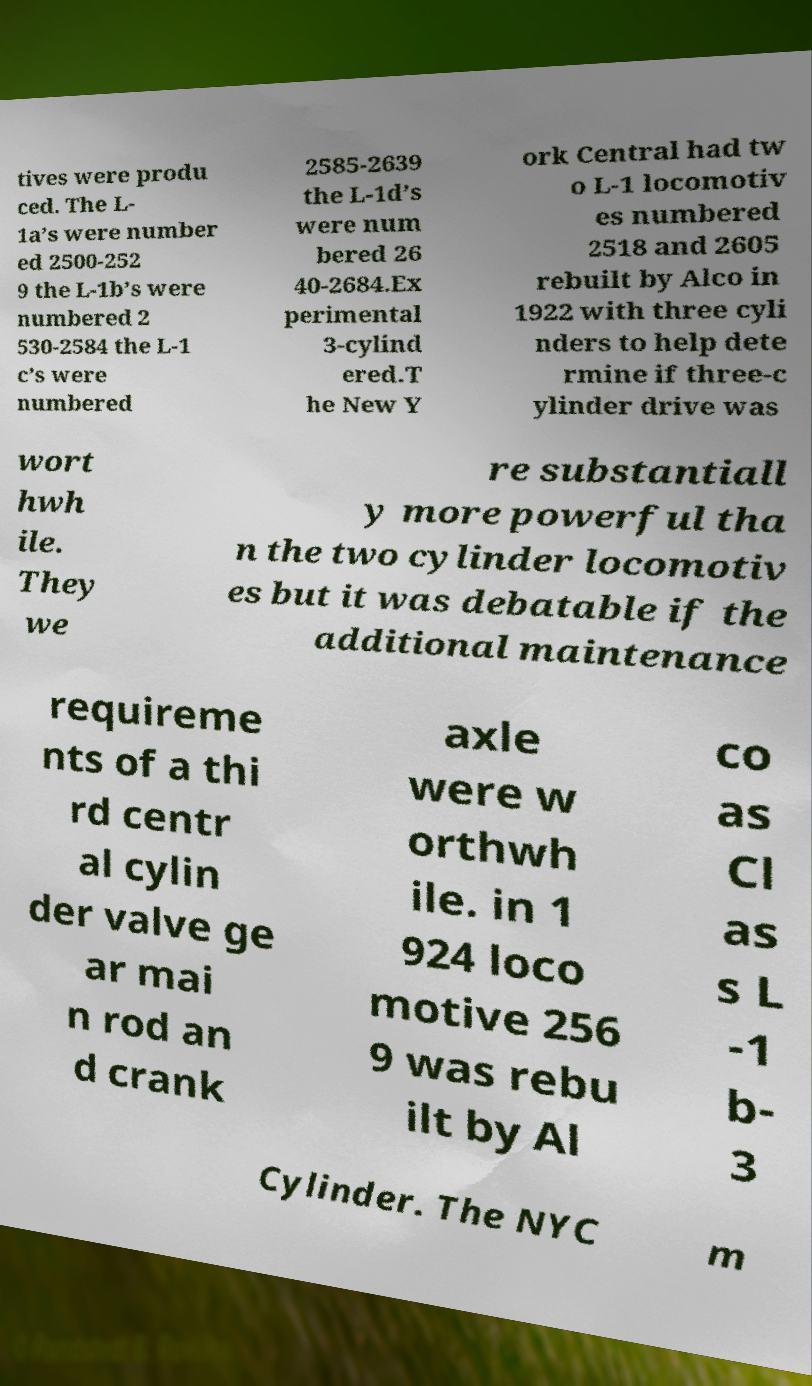Please identify and transcribe the text found in this image. tives were produ ced. The L- 1a’s were number ed 2500-252 9 the L-1b’s were numbered 2 530-2584 the L-1 c’s were numbered 2585-2639 the L-1d’s were num bered 26 40-2684.Ex perimental 3-cylind ered.T he New Y ork Central had tw o L-1 locomotiv es numbered 2518 and 2605 rebuilt by Alco in 1922 with three cyli nders to help dete rmine if three-c ylinder drive was wort hwh ile. They we re substantiall y more powerful tha n the two cylinder locomotiv es but it was debatable if the additional maintenance requireme nts of a thi rd centr al cylin der valve ge ar mai n rod an d crank axle were w orthwh ile. in 1 924 loco motive 256 9 was rebu ilt by Al co as Cl as s L -1 b- 3 Cylinder. The NYC m 